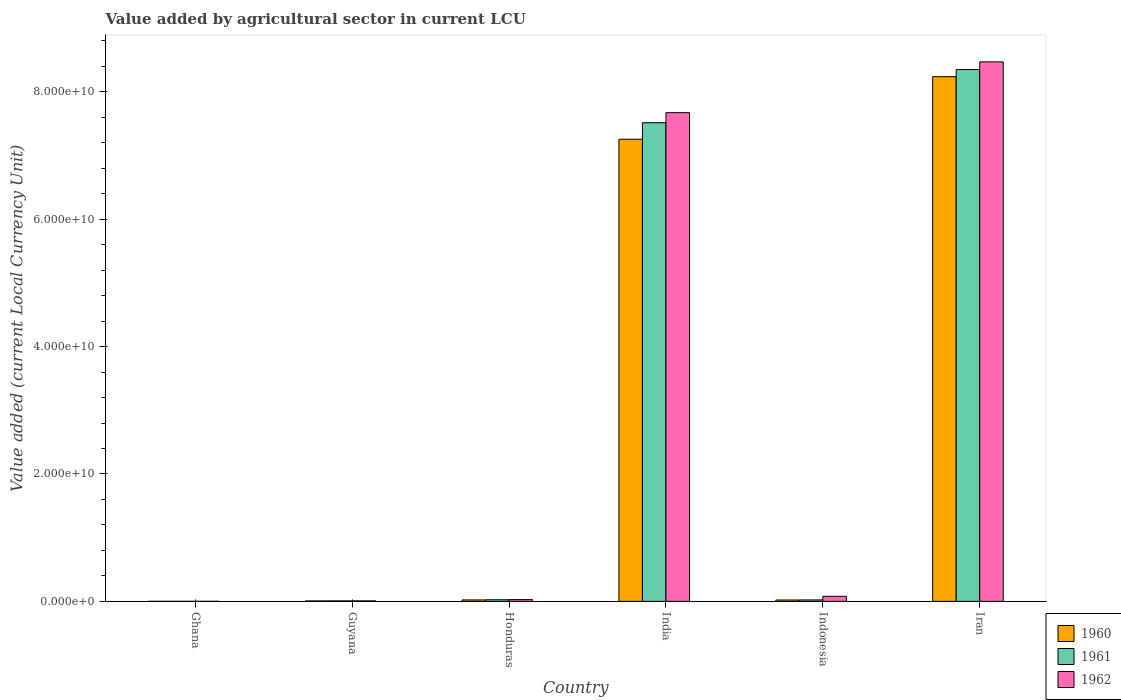Are the number of bars per tick equal to the number of legend labels?
Keep it short and to the point. Yes. What is the value added by agricultural sector in 1962 in Ghana?
Offer a terse response. 3.74e+04. Across all countries, what is the maximum value added by agricultural sector in 1961?
Provide a succinct answer. 8.35e+1. Across all countries, what is the minimum value added by agricultural sector in 1961?
Your answer should be compact. 3.29e+04. In which country was the value added by agricultural sector in 1962 maximum?
Offer a terse response. Iran. What is the total value added by agricultural sector in 1961 in the graph?
Your answer should be compact. 1.59e+11. What is the difference between the value added by agricultural sector in 1961 in Guyana and that in Honduras?
Keep it short and to the point. -1.75e+08. What is the difference between the value added by agricultural sector in 1960 in India and the value added by agricultural sector in 1962 in Honduras?
Make the answer very short. 7.23e+1. What is the average value added by agricultural sector in 1960 per country?
Offer a terse response. 2.59e+1. What is the difference between the value added by agricultural sector of/in 1960 and value added by agricultural sector of/in 1961 in Guyana?
Your response must be concise. -7.20e+06. In how many countries, is the value added by agricultural sector in 1962 greater than 16000000000 LCU?
Provide a short and direct response. 2. What is the ratio of the value added by agricultural sector in 1960 in India to that in Iran?
Your answer should be compact. 0.88. Is the value added by agricultural sector in 1961 in Ghana less than that in India?
Your answer should be compact. Yes. What is the difference between the highest and the second highest value added by agricultural sector in 1961?
Make the answer very short. 7.49e+1. What is the difference between the highest and the lowest value added by agricultural sector in 1960?
Offer a very short reply. 8.24e+1. In how many countries, is the value added by agricultural sector in 1962 greater than the average value added by agricultural sector in 1962 taken over all countries?
Ensure brevity in your answer.  2. What does the 1st bar from the left in Iran represents?
Provide a succinct answer. 1960. What does the 3rd bar from the right in Guyana represents?
Give a very brief answer. 1960. Does the graph contain any zero values?
Ensure brevity in your answer.  No. How are the legend labels stacked?
Your answer should be very brief. Vertical. What is the title of the graph?
Provide a succinct answer. Value added by agricultural sector in current LCU. What is the label or title of the Y-axis?
Keep it short and to the point. Value added (current Local Currency Unit). What is the Value added (current Local Currency Unit) in 1960 in Ghana?
Offer a very short reply. 3.55e+04. What is the Value added (current Local Currency Unit) of 1961 in Ghana?
Your response must be concise. 3.29e+04. What is the Value added (current Local Currency Unit) in 1962 in Ghana?
Offer a terse response. 3.74e+04. What is the Value added (current Local Currency Unit) in 1960 in Guyana?
Make the answer very short. 6.88e+07. What is the Value added (current Local Currency Unit) in 1961 in Guyana?
Offer a terse response. 7.60e+07. What is the Value added (current Local Currency Unit) of 1962 in Guyana?
Ensure brevity in your answer.  7.84e+07. What is the Value added (current Local Currency Unit) of 1960 in Honduras?
Offer a terse response. 2.27e+08. What is the Value added (current Local Currency Unit) in 1961 in Honduras?
Ensure brevity in your answer.  2.51e+08. What is the Value added (current Local Currency Unit) of 1962 in Honduras?
Keep it short and to the point. 2.74e+08. What is the Value added (current Local Currency Unit) of 1960 in India?
Keep it short and to the point. 7.26e+1. What is the Value added (current Local Currency Unit) in 1961 in India?
Provide a succinct answer. 7.52e+1. What is the Value added (current Local Currency Unit) of 1962 in India?
Make the answer very short. 7.67e+1. What is the Value added (current Local Currency Unit) of 1960 in Indonesia?
Your answer should be very brief. 2.12e+08. What is the Value added (current Local Currency Unit) in 1961 in Indonesia?
Provide a short and direct response. 2.27e+08. What is the Value added (current Local Currency Unit) of 1962 in Indonesia?
Ensure brevity in your answer.  7.93e+08. What is the Value added (current Local Currency Unit) in 1960 in Iran?
Make the answer very short. 8.24e+1. What is the Value added (current Local Currency Unit) in 1961 in Iran?
Keep it short and to the point. 8.35e+1. What is the Value added (current Local Currency Unit) of 1962 in Iran?
Give a very brief answer. 8.47e+1. Across all countries, what is the maximum Value added (current Local Currency Unit) of 1960?
Ensure brevity in your answer.  8.24e+1. Across all countries, what is the maximum Value added (current Local Currency Unit) in 1961?
Keep it short and to the point. 8.35e+1. Across all countries, what is the maximum Value added (current Local Currency Unit) of 1962?
Offer a terse response. 8.47e+1. Across all countries, what is the minimum Value added (current Local Currency Unit) in 1960?
Your answer should be compact. 3.55e+04. Across all countries, what is the minimum Value added (current Local Currency Unit) in 1961?
Your answer should be very brief. 3.29e+04. Across all countries, what is the minimum Value added (current Local Currency Unit) in 1962?
Ensure brevity in your answer.  3.74e+04. What is the total Value added (current Local Currency Unit) of 1960 in the graph?
Provide a succinct answer. 1.55e+11. What is the total Value added (current Local Currency Unit) of 1961 in the graph?
Keep it short and to the point. 1.59e+11. What is the total Value added (current Local Currency Unit) of 1962 in the graph?
Keep it short and to the point. 1.63e+11. What is the difference between the Value added (current Local Currency Unit) in 1960 in Ghana and that in Guyana?
Your response must be concise. -6.88e+07. What is the difference between the Value added (current Local Currency Unit) of 1961 in Ghana and that in Guyana?
Your response must be concise. -7.60e+07. What is the difference between the Value added (current Local Currency Unit) in 1962 in Ghana and that in Guyana?
Ensure brevity in your answer.  -7.84e+07. What is the difference between the Value added (current Local Currency Unit) in 1960 in Ghana and that in Honduras?
Your answer should be compact. -2.27e+08. What is the difference between the Value added (current Local Currency Unit) of 1961 in Ghana and that in Honduras?
Offer a very short reply. -2.51e+08. What is the difference between the Value added (current Local Currency Unit) in 1962 in Ghana and that in Honduras?
Your answer should be very brief. -2.74e+08. What is the difference between the Value added (current Local Currency Unit) in 1960 in Ghana and that in India?
Offer a terse response. -7.26e+1. What is the difference between the Value added (current Local Currency Unit) in 1961 in Ghana and that in India?
Keep it short and to the point. -7.52e+1. What is the difference between the Value added (current Local Currency Unit) of 1962 in Ghana and that in India?
Your answer should be very brief. -7.67e+1. What is the difference between the Value added (current Local Currency Unit) in 1960 in Ghana and that in Indonesia?
Offer a terse response. -2.12e+08. What is the difference between the Value added (current Local Currency Unit) in 1961 in Ghana and that in Indonesia?
Give a very brief answer. -2.27e+08. What is the difference between the Value added (current Local Currency Unit) of 1962 in Ghana and that in Indonesia?
Your answer should be very brief. -7.93e+08. What is the difference between the Value added (current Local Currency Unit) in 1960 in Ghana and that in Iran?
Provide a succinct answer. -8.24e+1. What is the difference between the Value added (current Local Currency Unit) in 1961 in Ghana and that in Iran?
Provide a succinct answer. -8.35e+1. What is the difference between the Value added (current Local Currency Unit) in 1962 in Ghana and that in Iran?
Keep it short and to the point. -8.47e+1. What is the difference between the Value added (current Local Currency Unit) in 1960 in Guyana and that in Honduras?
Give a very brief answer. -1.58e+08. What is the difference between the Value added (current Local Currency Unit) of 1961 in Guyana and that in Honduras?
Give a very brief answer. -1.75e+08. What is the difference between the Value added (current Local Currency Unit) of 1962 in Guyana and that in Honduras?
Give a very brief answer. -1.96e+08. What is the difference between the Value added (current Local Currency Unit) in 1960 in Guyana and that in India?
Your response must be concise. -7.25e+1. What is the difference between the Value added (current Local Currency Unit) of 1961 in Guyana and that in India?
Your answer should be very brief. -7.51e+1. What is the difference between the Value added (current Local Currency Unit) in 1962 in Guyana and that in India?
Offer a very short reply. -7.67e+1. What is the difference between the Value added (current Local Currency Unit) of 1960 in Guyana and that in Indonesia?
Your response must be concise. -1.43e+08. What is the difference between the Value added (current Local Currency Unit) in 1961 in Guyana and that in Indonesia?
Your answer should be very brief. -1.51e+08. What is the difference between the Value added (current Local Currency Unit) of 1962 in Guyana and that in Indonesia?
Offer a terse response. -7.15e+08. What is the difference between the Value added (current Local Currency Unit) of 1960 in Guyana and that in Iran?
Provide a short and direct response. -8.23e+1. What is the difference between the Value added (current Local Currency Unit) in 1961 in Guyana and that in Iran?
Give a very brief answer. -8.34e+1. What is the difference between the Value added (current Local Currency Unit) in 1962 in Guyana and that in Iran?
Your answer should be very brief. -8.46e+1. What is the difference between the Value added (current Local Currency Unit) in 1960 in Honduras and that in India?
Provide a short and direct response. -7.23e+1. What is the difference between the Value added (current Local Currency Unit) of 1961 in Honduras and that in India?
Provide a short and direct response. -7.49e+1. What is the difference between the Value added (current Local Currency Unit) of 1962 in Honduras and that in India?
Provide a short and direct response. -7.65e+1. What is the difference between the Value added (current Local Currency Unit) of 1960 in Honduras and that in Indonesia?
Give a very brief answer. 1.50e+07. What is the difference between the Value added (current Local Currency Unit) in 1961 in Honduras and that in Indonesia?
Make the answer very short. 2.42e+07. What is the difference between the Value added (current Local Currency Unit) of 1962 in Honduras and that in Indonesia?
Your answer should be very brief. -5.18e+08. What is the difference between the Value added (current Local Currency Unit) in 1960 in Honduras and that in Iran?
Your response must be concise. -8.22e+1. What is the difference between the Value added (current Local Currency Unit) of 1961 in Honduras and that in Iran?
Provide a short and direct response. -8.33e+1. What is the difference between the Value added (current Local Currency Unit) of 1962 in Honduras and that in Iran?
Offer a very short reply. -8.44e+1. What is the difference between the Value added (current Local Currency Unit) in 1960 in India and that in Indonesia?
Offer a very short reply. 7.24e+1. What is the difference between the Value added (current Local Currency Unit) in 1961 in India and that in Indonesia?
Your response must be concise. 7.49e+1. What is the difference between the Value added (current Local Currency Unit) in 1962 in India and that in Indonesia?
Offer a very short reply. 7.59e+1. What is the difference between the Value added (current Local Currency Unit) in 1960 in India and that in Iran?
Provide a short and direct response. -9.82e+09. What is the difference between the Value added (current Local Currency Unit) of 1961 in India and that in Iran?
Provide a short and direct response. -8.35e+09. What is the difference between the Value added (current Local Currency Unit) in 1962 in India and that in Iran?
Ensure brevity in your answer.  -7.98e+09. What is the difference between the Value added (current Local Currency Unit) in 1960 in Indonesia and that in Iran?
Keep it short and to the point. -8.22e+1. What is the difference between the Value added (current Local Currency Unit) of 1961 in Indonesia and that in Iran?
Your response must be concise. -8.33e+1. What is the difference between the Value added (current Local Currency Unit) in 1962 in Indonesia and that in Iran?
Your response must be concise. -8.39e+1. What is the difference between the Value added (current Local Currency Unit) of 1960 in Ghana and the Value added (current Local Currency Unit) of 1961 in Guyana?
Give a very brief answer. -7.60e+07. What is the difference between the Value added (current Local Currency Unit) of 1960 in Ghana and the Value added (current Local Currency Unit) of 1962 in Guyana?
Make the answer very short. -7.84e+07. What is the difference between the Value added (current Local Currency Unit) of 1961 in Ghana and the Value added (current Local Currency Unit) of 1962 in Guyana?
Keep it short and to the point. -7.84e+07. What is the difference between the Value added (current Local Currency Unit) in 1960 in Ghana and the Value added (current Local Currency Unit) in 1961 in Honduras?
Keep it short and to the point. -2.51e+08. What is the difference between the Value added (current Local Currency Unit) of 1960 in Ghana and the Value added (current Local Currency Unit) of 1962 in Honduras?
Provide a succinct answer. -2.74e+08. What is the difference between the Value added (current Local Currency Unit) in 1961 in Ghana and the Value added (current Local Currency Unit) in 1962 in Honduras?
Ensure brevity in your answer.  -2.74e+08. What is the difference between the Value added (current Local Currency Unit) of 1960 in Ghana and the Value added (current Local Currency Unit) of 1961 in India?
Offer a terse response. -7.52e+1. What is the difference between the Value added (current Local Currency Unit) of 1960 in Ghana and the Value added (current Local Currency Unit) of 1962 in India?
Give a very brief answer. -7.67e+1. What is the difference between the Value added (current Local Currency Unit) of 1961 in Ghana and the Value added (current Local Currency Unit) of 1962 in India?
Make the answer very short. -7.67e+1. What is the difference between the Value added (current Local Currency Unit) of 1960 in Ghana and the Value added (current Local Currency Unit) of 1961 in Indonesia?
Make the answer very short. -2.27e+08. What is the difference between the Value added (current Local Currency Unit) of 1960 in Ghana and the Value added (current Local Currency Unit) of 1962 in Indonesia?
Provide a short and direct response. -7.93e+08. What is the difference between the Value added (current Local Currency Unit) of 1961 in Ghana and the Value added (current Local Currency Unit) of 1962 in Indonesia?
Ensure brevity in your answer.  -7.93e+08. What is the difference between the Value added (current Local Currency Unit) of 1960 in Ghana and the Value added (current Local Currency Unit) of 1961 in Iran?
Provide a succinct answer. -8.35e+1. What is the difference between the Value added (current Local Currency Unit) in 1960 in Ghana and the Value added (current Local Currency Unit) in 1962 in Iran?
Provide a succinct answer. -8.47e+1. What is the difference between the Value added (current Local Currency Unit) of 1961 in Ghana and the Value added (current Local Currency Unit) of 1962 in Iran?
Make the answer very short. -8.47e+1. What is the difference between the Value added (current Local Currency Unit) of 1960 in Guyana and the Value added (current Local Currency Unit) of 1961 in Honduras?
Your answer should be very brief. -1.82e+08. What is the difference between the Value added (current Local Currency Unit) of 1960 in Guyana and the Value added (current Local Currency Unit) of 1962 in Honduras?
Offer a terse response. -2.06e+08. What is the difference between the Value added (current Local Currency Unit) in 1961 in Guyana and the Value added (current Local Currency Unit) in 1962 in Honduras?
Your response must be concise. -1.98e+08. What is the difference between the Value added (current Local Currency Unit) in 1960 in Guyana and the Value added (current Local Currency Unit) in 1961 in India?
Offer a terse response. -7.51e+1. What is the difference between the Value added (current Local Currency Unit) in 1960 in Guyana and the Value added (current Local Currency Unit) in 1962 in India?
Make the answer very short. -7.67e+1. What is the difference between the Value added (current Local Currency Unit) in 1961 in Guyana and the Value added (current Local Currency Unit) in 1962 in India?
Your response must be concise. -7.67e+1. What is the difference between the Value added (current Local Currency Unit) in 1960 in Guyana and the Value added (current Local Currency Unit) in 1961 in Indonesia?
Your answer should be compact. -1.58e+08. What is the difference between the Value added (current Local Currency Unit) of 1960 in Guyana and the Value added (current Local Currency Unit) of 1962 in Indonesia?
Your answer should be very brief. -7.24e+08. What is the difference between the Value added (current Local Currency Unit) of 1961 in Guyana and the Value added (current Local Currency Unit) of 1962 in Indonesia?
Your answer should be very brief. -7.17e+08. What is the difference between the Value added (current Local Currency Unit) of 1960 in Guyana and the Value added (current Local Currency Unit) of 1961 in Iran?
Offer a very short reply. -8.34e+1. What is the difference between the Value added (current Local Currency Unit) in 1960 in Guyana and the Value added (current Local Currency Unit) in 1962 in Iran?
Ensure brevity in your answer.  -8.46e+1. What is the difference between the Value added (current Local Currency Unit) of 1961 in Guyana and the Value added (current Local Currency Unit) of 1962 in Iran?
Give a very brief answer. -8.46e+1. What is the difference between the Value added (current Local Currency Unit) of 1960 in Honduras and the Value added (current Local Currency Unit) of 1961 in India?
Keep it short and to the point. -7.49e+1. What is the difference between the Value added (current Local Currency Unit) of 1960 in Honduras and the Value added (current Local Currency Unit) of 1962 in India?
Your answer should be compact. -7.65e+1. What is the difference between the Value added (current Local Currency Unit) in 1961 in Honduras and the Value added (current Local Currency Unit) in 1962 in India?
Keep it short and to the point. -7.65e+1. What is the difference between the Value added (current Local Currency Unit) in 1960 in Honduras and the Value added (current Local Currency Unit) in 1962 in Indonesia?
Offer a terse response. -5.66e+08. What is the difference between the Value added (current Local Currency Unit) of 1961 in Honduras and the Value added (current Local Currency Unit) of 1962 in Indonesia?
Give a very brief answer. -5.42e+08. What is the difference between the Value added (current Local Currency Unit) in 1960 in Honduras and the Value added (current Local Currency Unit) in 1961 in Iran?
Provide a short and direct response. -8.33e+1. What is the difference between the Value added (current Local Currency Unit) in 1960 in Honduras and the Value added (current Local Currency Unit) in 1962 in Iran?
Your answer should be compact. -8.45e+1. What is the difference between the Value added (current Local Currency Unit) in 1961 in Honduras and the Value added (current Local Currency Unit) in 1962 in Iran?
Keep it short and to the point. -8.45e+1. What is the difference between the Value added (current Local Currency Unit) of 1960 in India and the Value added (current Local Currency Unit) of 1961 in Indonesia?
Offer a very short reply. 7.23e+1. What is the difference between the Value added (current Local Currency Unit) of 1960 in India and the Value added (current Local Currency Unit) of 1962 in Indonesia?
Your answer should be very brief. 7.18e+1. What is the difference between the Value added (current Local Currency Unit) of 1961 in India and the Value added (current Local Currency Unit) of 1962 in Indonesia?
Your answer should be very brief. 7.44e+1. What is the difference between the Value added (current Local Currency Unit) of 1960 in India and the Value added (current Local Currency Unit) of 1961 in Iran?
Make the answer very short. -1.09e+1. What is the difference between the Value added (current Local Currency Unit) of 1960 in India and the Value added (current Local Currency Unit) of 1962 in Iran?
Provide a succinct answer. -1.22e+1. What is the difference between the Value added (current Local Currency Unit) of 1961 in India and the Value added (current Local Currency Unit) of 1962 in Iran?
Your answer should be compact. -9.56e+09. What is the difference between the Value added (current Local Currency Unit) of 1960 in Indonesia and the Value added (current Local Currency Unit) of 1961 in Iran?
Offer a terse response. -8.33e+1. What is the difference between the Value added (current Local Currency Unit) of 1960 in Indonesia and the Value added (current Local Currency Unit) of 1962 in Iran?
Offer a very short reply. -8.45e+1. What is the difference between the Value added (current Local Currency Unit) of 1961 in Indonesia and the Value added (current Local Currency Unit) of 1962 in Iran?
Your answer should be compact. -8.45e+1. What is the average Value added (current Local Currency Unit) in 1960 per country?
Offer a very short reply. 2.59e+1. What is the average Value added (current Local Currency Unit) of 1961 per country?
Ensure brevity in your answer.  2.65e+1. What is the average Value added (current Local Currency Unit) of 1962 per country?
Offer a terse response. 2.71e+1. What is the difference between the Value added (current Local Currency Unit) of 1960 and Value added (current Local Currency Unit) of 1961 in Ghana?
Provide a short and direct response. 2600. What is the difference between the Value added (current Local Currency Unit) in 1960 and Value added (current Local Currency Unit) in 1962 in Ghana?
Keep it short and to the point. -1900. What is the difference between the Value added (current Local Currency Unit) of 1961 and Value added (current Local Currency Unit) of 1962 in Ghana?
Keep it short and to the point. -4500. What is the difference between the Value added (current Local Currency Unit) of 1960 and Value added (current Local Currency Unit) of 1961 in Guyana?
Keep it short and to the point. -7.20e+06. What is the difference between the Value added (current Local Currency Unit) of 1960 and Value added (current Local Currency Unit) of 1962 in Guyana?
Provide a succinct answer. -9.60e+06. What is the difference between the Value added (current Local Currency Unit) in 1961 and Value added (current Local Currency Unit) in 1962 in Guyana?
Give a very brief answer. -2.40e+06. What is the difference between the Value added (current Local Currency Unit) in 1960 and Value added (current Local Currency Unit) in 1961 in Honduras?
Your answer should be very brief. -2.42e+07. What is the difference between the Value added (current Local Currency Unit) of 1960 and Value added (current Local Currency Unit) of 1962 in Honduras?
Your answer should be very brief. -4.75e+07. What is the difference between the Value added (current Local Currency Unit) of 1961 and Value added (current Local Currency Unit) of 1962 in Honduras?
Your answer should be very brief. -2.33e+07. What is the difference between the Value added (current Local Currency Unit) of 1960 and Value added (current Local Currency Unit) of 1961 in India?
Keep it short and to the point. -2.59e+09. What is the difference between the Value added (current Local Currency Unit) of 1960 and Value added (current Local Currency Unit) of 1962 in India?
Your answer should be compact. -4.17e+09. What is the difference between the Value added (current Local Currency Unit) in 1961 and Value added (current Local Currency Unit) in 1962 in India?
Ensure brevity in your answer.  -1.58e+09. What is the difference between the Value added (current Local Currency Unit) in 1960 and Value added (current Local Currency Unit) in 1961 in Indonesia?
Give a very brief answer. -1.50e+07. What is the difference between the Value added (current Local Currency Unit) in 1960 and Value added (current Local Currency Unit) in 1962 in Indonesia?
Your answer should be compact. -5.81e+08. What is the difference between the Value added (current Local Currency Unit) of 1961 and Value added (current Local Currency Unit) of 1962 in Indonesia?
Offer a very short reply. -5.66e+08. What is the difference between the Value added (current Local Currency Unit) in 1960 and Value added (current Local Currency Unit) in 1961 in Iran?
Offer a terse response. -1.12e+09. What is the difference between the Value added (current Local Currency Unit) in 1960 and Value added (current Local Currency Unit) in 1962 in Iran?
Your answer should be very brief. -2.33e+09. What is the difference between the Value added (current Local Currency Unit) of 1961 and Value added (current Local Currency Unit) of 1962 in Iran?
Your response must be concise. -1.21e+09. What is the ratio of the Value added (current Local Currency Unit) of 1960 in Ghana to that in Guyana?
Provide a succinct answer. 0. What is the ratio of the Value added (current Local Currency Unit) of 1962 in Ghana to that in Guyana?
Offer a very short reply. 0. What is the ratio of the Value added (current Local Currency Unit) in 1960 in Ghana to that in Honduras?
Give a very brief answer. 0. What is the ratio of the Value added (current Local Currency Unit) of 1961 in Ghana to that in Honduras?
Provide a succinct answer. 0. What is the ratio of the Value added (current Local Currency Unit) in 1962 in Ghana to that in Honduras?
Offer a very short reply. 0. What is the ratio of the Value added (current Local Currency Unit) of 1962 in Ghana to that in India?
Give a very brief answer. 0. What is the ratio of the Value added (current Local Currency Unit) in 1962 in Ghana to that in Indonesia?
Offer a terse response. 0. What is the ratio of the Value added (current Local Currency Unit) in 1960 in Ghana to that in Iran?
Give a very brief answer. 0. What is the ratio of the Value added (current Local Currency Unit) in 1961 in Ghana to that in Iran?
Keep it short and to the point. 0. What is the ratio of the Value added (current Local Currency Unit) in 1962 in Ghana to that in Iran?
Provide a succinct answer. 0. What is the ratio of the Value added (current Local Currency Unit) of 1960 in Guyana to that in Honduras?
Offer a terse response. 0.3. What is the ratio of the Value added (current Local Currency Unit) in 1961 in Guyana to that in Honduras?
Keep it short and to the point. 0.3. What is the ratio of the Value added (current Local Currency Unit) of 1962 in Guyana to that in Honduras?
Offer a very short reply. 0.29. What is the ratio of the Value added (current Local Currency Unit) in 1960 in Guyana to that in India?
Ensure brevity in your answer.  0. What is the ratio of the Value added (current Local Currency Unit) in 1962 in Guyana to that in India?
Make the answer very short. 0. What is the ratio of the Value added (current Local Currency Unit) of 1960 in Guyana to that in Indonesia?
Offer a very short reply. 0.32. What is the ratio of the Value added (current Local Currency Unit) in 1961 in Guyana to that in Indonesia?
Make the answer very short. 0.33. What is the ratio of the Value added (current Local Currency Unit) in 1962 in Guyana to that in Indonesia?
Your answer should be compact. 0.1. What is the ratio of the Value added (current Local Currency Unit) of 1960 in Guyana to that in Iran?
Offer a very short reply. 0. What is the ratio of the Value added (current Local Currency Unit) of 1961 in Guyana to that in Iran?
Your answer should be very brief. 0. What is the ratio of the Value added (current Local Currency Unit) in 1962 in Guyana to that in Iran?
Offer a very short reply. 0. What is the ratio of the Value added (current Local Currency Unit) in 1960 in Honduras to that in India?
Ensure brevity in your answer.  0. What is the ratio of the Value added (current Local Currency Unit) in 1961 in Honduras to that in India?
Ensure brevity in your answer.  0. What is the ratio of the Value added (current Local Currency Unit) of 1962 in Honduras to that in India?
Give a very brief answer. 0. What is the ratio of the Value added (current Local Currency Unit) of 1960 in Honduras to that in Indonesia?
Make the answer very short. 1.07. What is the ratio of the Value added (current Local Currency Unit) in 1961 in Honduras to that in Indonesia?
Provide a succinct answer. 1.11. What is the ratio of the Value added (current Local Currency Unit) in 1962 in Honduras to that in Indonesia?
Provide a short and direct response. 0.35. What is the ratio of the Value added (current Local Currency Unit) of 1960 in Honduras to that in Iran?
Your answer should be compact. 0. What is the ratio of the Value added (current Local Currency Unit) of 1961 in Honduras to that in Iran?
Keep it short and to the point. 0. What is the ratio of the Value added (current Local Currency Unit) in 1962 in Honduras to that in Iran?
Provide a short and direct response. 0. What is the ratio of the Value added (current Local Currency Unit) in 1960 in India to that in Indonesia?
Provide a succinct answer. 342.29. What is the ratio of the Value added (current Local Currency Unit) in 1961 in India to that in Indonesia?
Ensure brevity in your answer.  331.1. What is the ratio of the Value added (current Local Currency Unit) of 1962 in India to that in Indonesia?
Your response must be concise. 96.77. What is the ratio of the Value added (current Local Currency Unit) in 1960 in India to that in Iran?
Provide a succinct answer. 0.88. What is the ratio of the Value added (current Local Currency Unit) in 1961 in India to that in Iran?
Provide a short and direct response. 0.9. What is the ratio of the Value added (current Local Currency Unit) in 1962 in India to that in Iran?
Offer a very short reply. 0.91. What is the ratio of the Value added (current Local Currency Unit) of 1960 in Indonesia to that in Iran?
Give a very brief answer. 0. What is the ratio of the Value added (current Local Currency Unit) in 1961 in Indonesia to that in Iran?
Your answer should be compact. 0. What is the ratio of the Value added (current Local Currency Unit) in 1962 in Indonesia to that in Iran?
Your answer should be compact. 0.01. What is the difference between the highest and the second highest Value added (current Local Currency Unit) of 1960?
Offer a very short reply. 9.82e+09. What is the difference between the highest and the second highest Value added (current Local Currency Unit) in 1961?
Keep it short and to the point. 8.35e+09. What is the difference between the highest and the second highest Value added (current Local Currency Unit) in 1962?
Give a very brief answer. 7.98e+09. What is the difference between the highest and the lowest Value added (current Local Currency Unit) in 1960?
Your answer should be very brief. 8.24e+1. What is the difference between the highest and the lowest Value added (current Local Currency Unit) of 1961?
Offer a terse response. 8.35e+1. What is the difference between the highest and the lowest Value added (current Local Currency Unit) in 1962?
Offer a very short reply. 8.47e+1. 